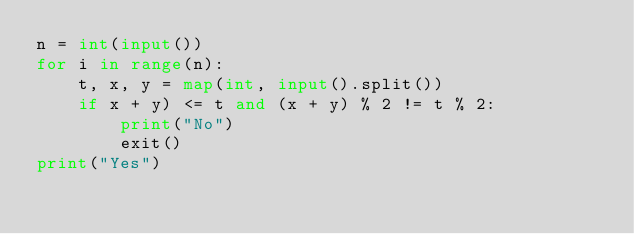Convert code to text. <code><loc_0><loc_0><loc_500><loc_500><_Python_>n = int(input())
for i in range(n):
    t, x, y = map(int, input().split())
    if x + y) <= t and (x + y) % 2 != t % 2:
        print("No")
        exit()
print("Yes")</code> 